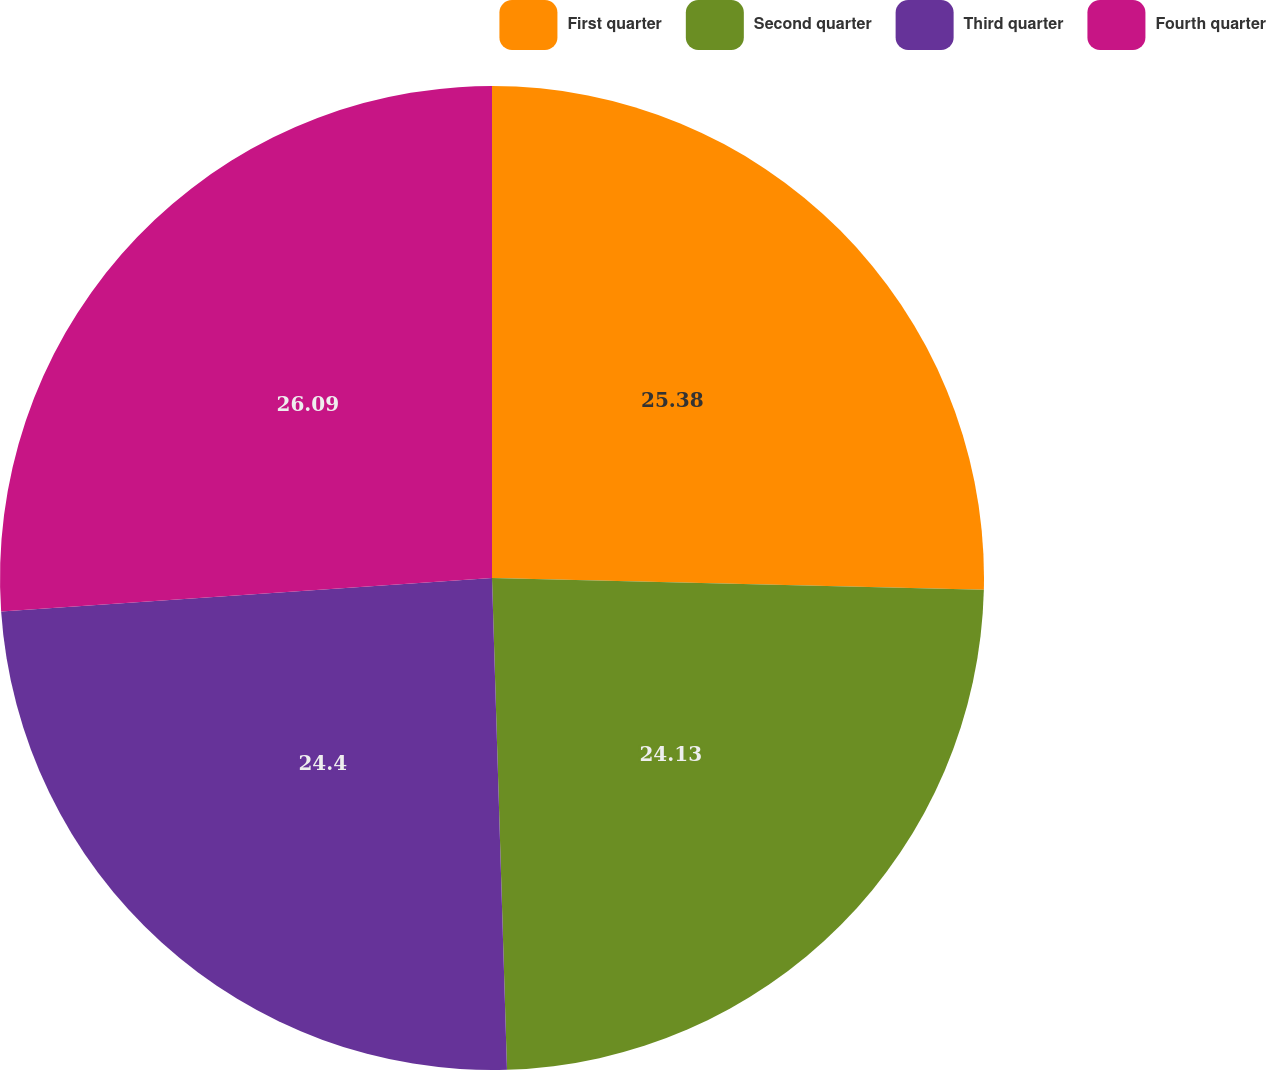Convert chart. <chart><loc_0><loc_0><loc_500><loc_500><pie_chart><fcel>First quarter<fcel>Second quarter<fcel>Third quarter<fcel>Fourth quarter<nl><fcel>25.38%<fcel>24.13%<fcel>24.4%<fcel>26.08%<nl></chart> 